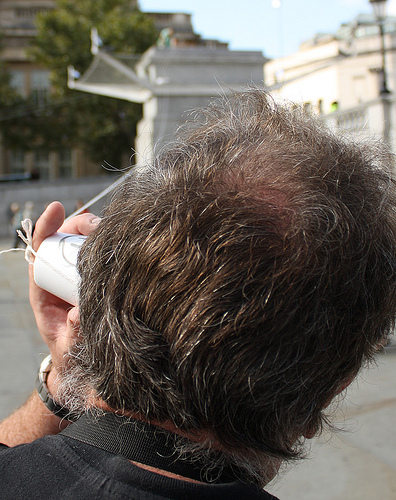<image>
Is there a cup on the head? Yes. Looking at the image, I can see the cup is positioned on top of the head, with the head providing support. 